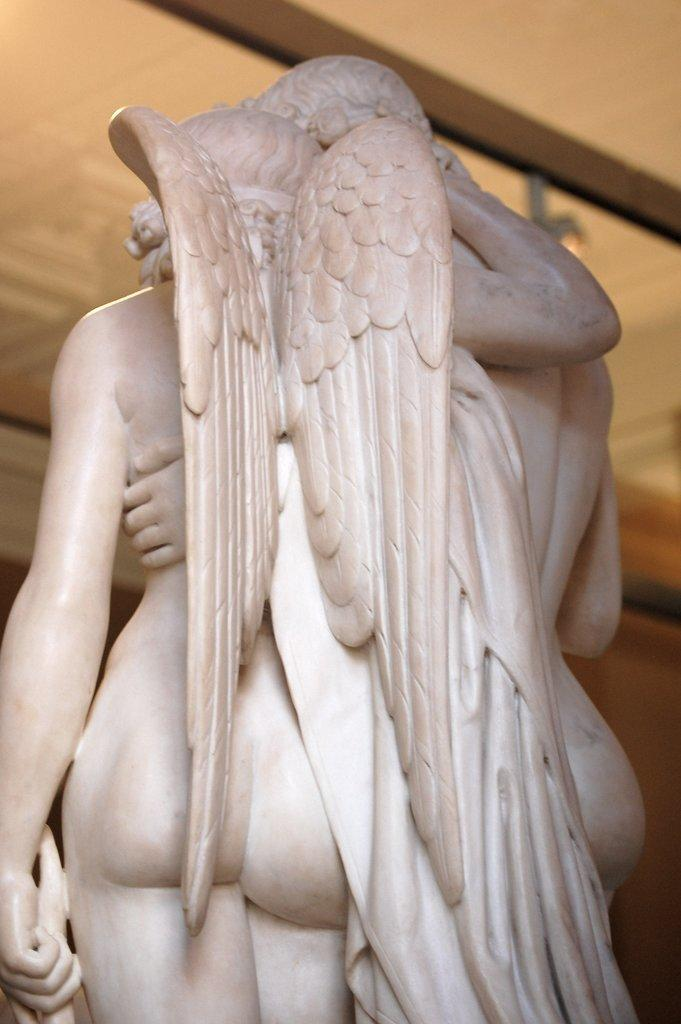What type of artwork can be seen in the image? There are sculptures in the image. What is above the sculptures in the image? There is a ceiling in the image. What type of pickle is hanging from the ceiling in the image? There is no pickle present in the image; it only features sculptures and a ceiling. 